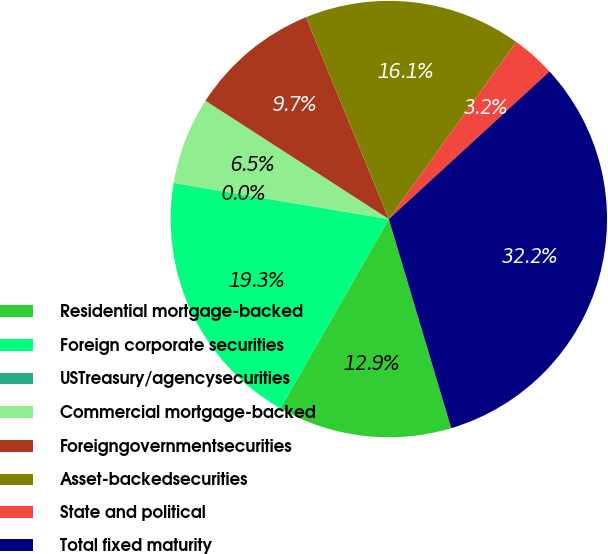Convert chart. <chart><loc_0><loc_0><loc_500><loc_500><pie_chart><fcel>Residential mortgage-backed<fcel>Foreign corporate securities<fcel>USTreasury/agencysecurities<fcel>Commercial mortgage-backed<fcel>Foreigngovernmentsecurities<fcel>Asset-backedsecurities<fcel>State and political<fcel>Total fixed maturity<nl><fcel>12.9%<fcel>19.34%<fcel>0.03%<fcel>6.47%<fcel>9.68%<fcel>16.12%<fcel>3.25%<fcel>32.21%<nl></chart> 